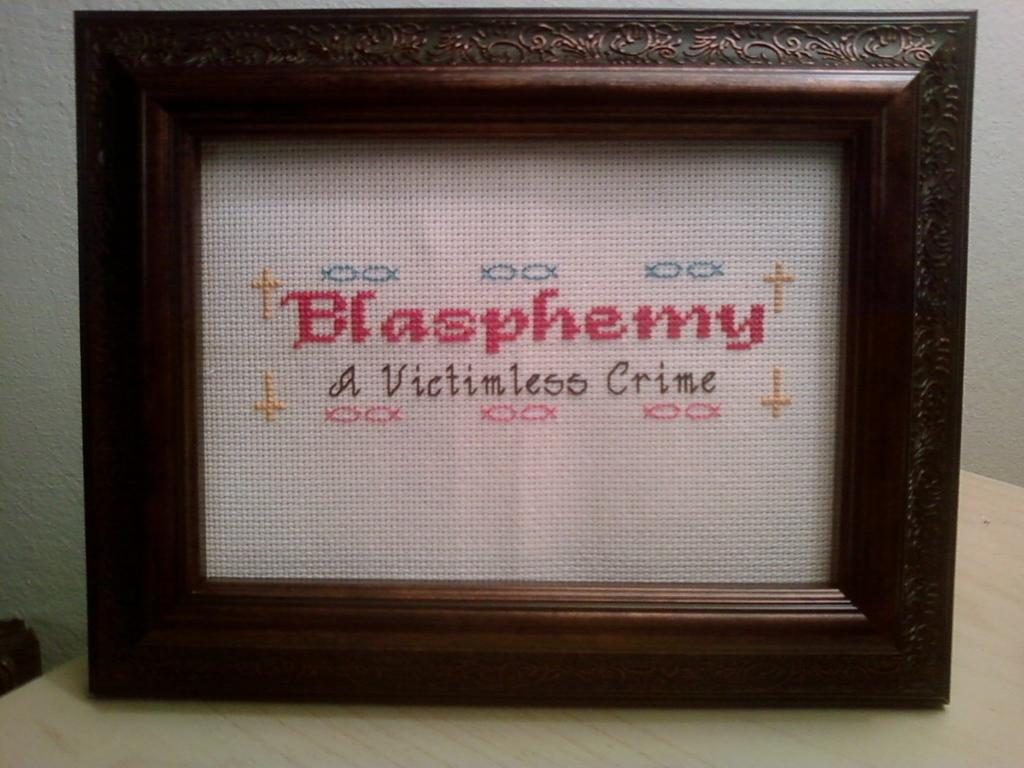<image>
Create a compact narrative representing the image presented. Framed fiber art that says Blasphemy a Victimless Crime. 